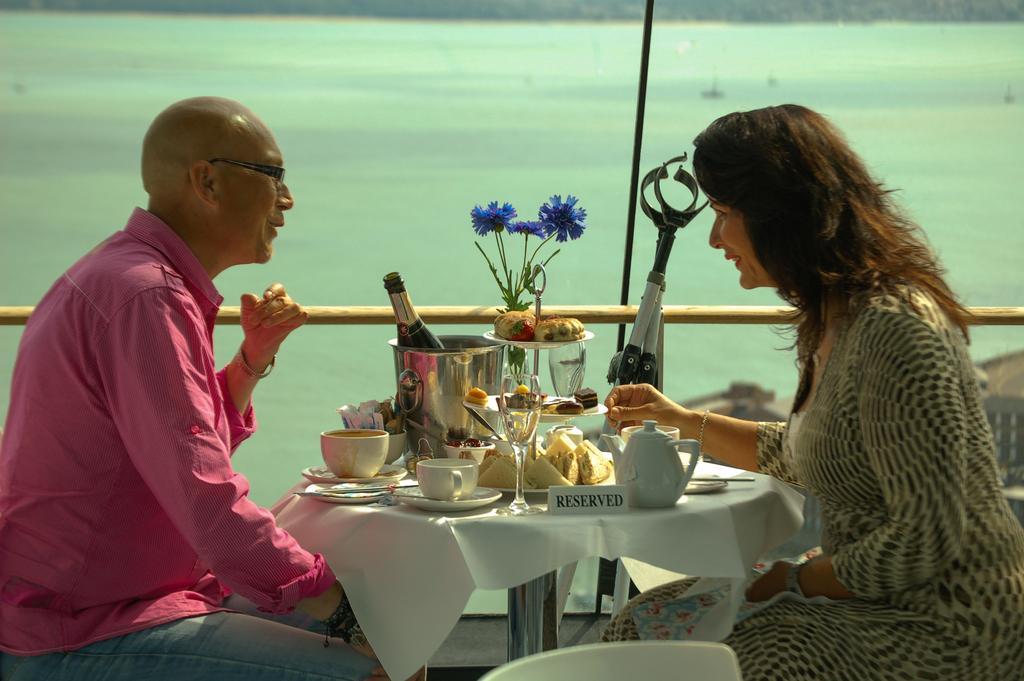Could you give a brief overview of what you see in this image? There is a man and woman sitting at the table. There are wine bottle,cups,glasses,food items,flower vase on the table. In the background there is a pole and water. 